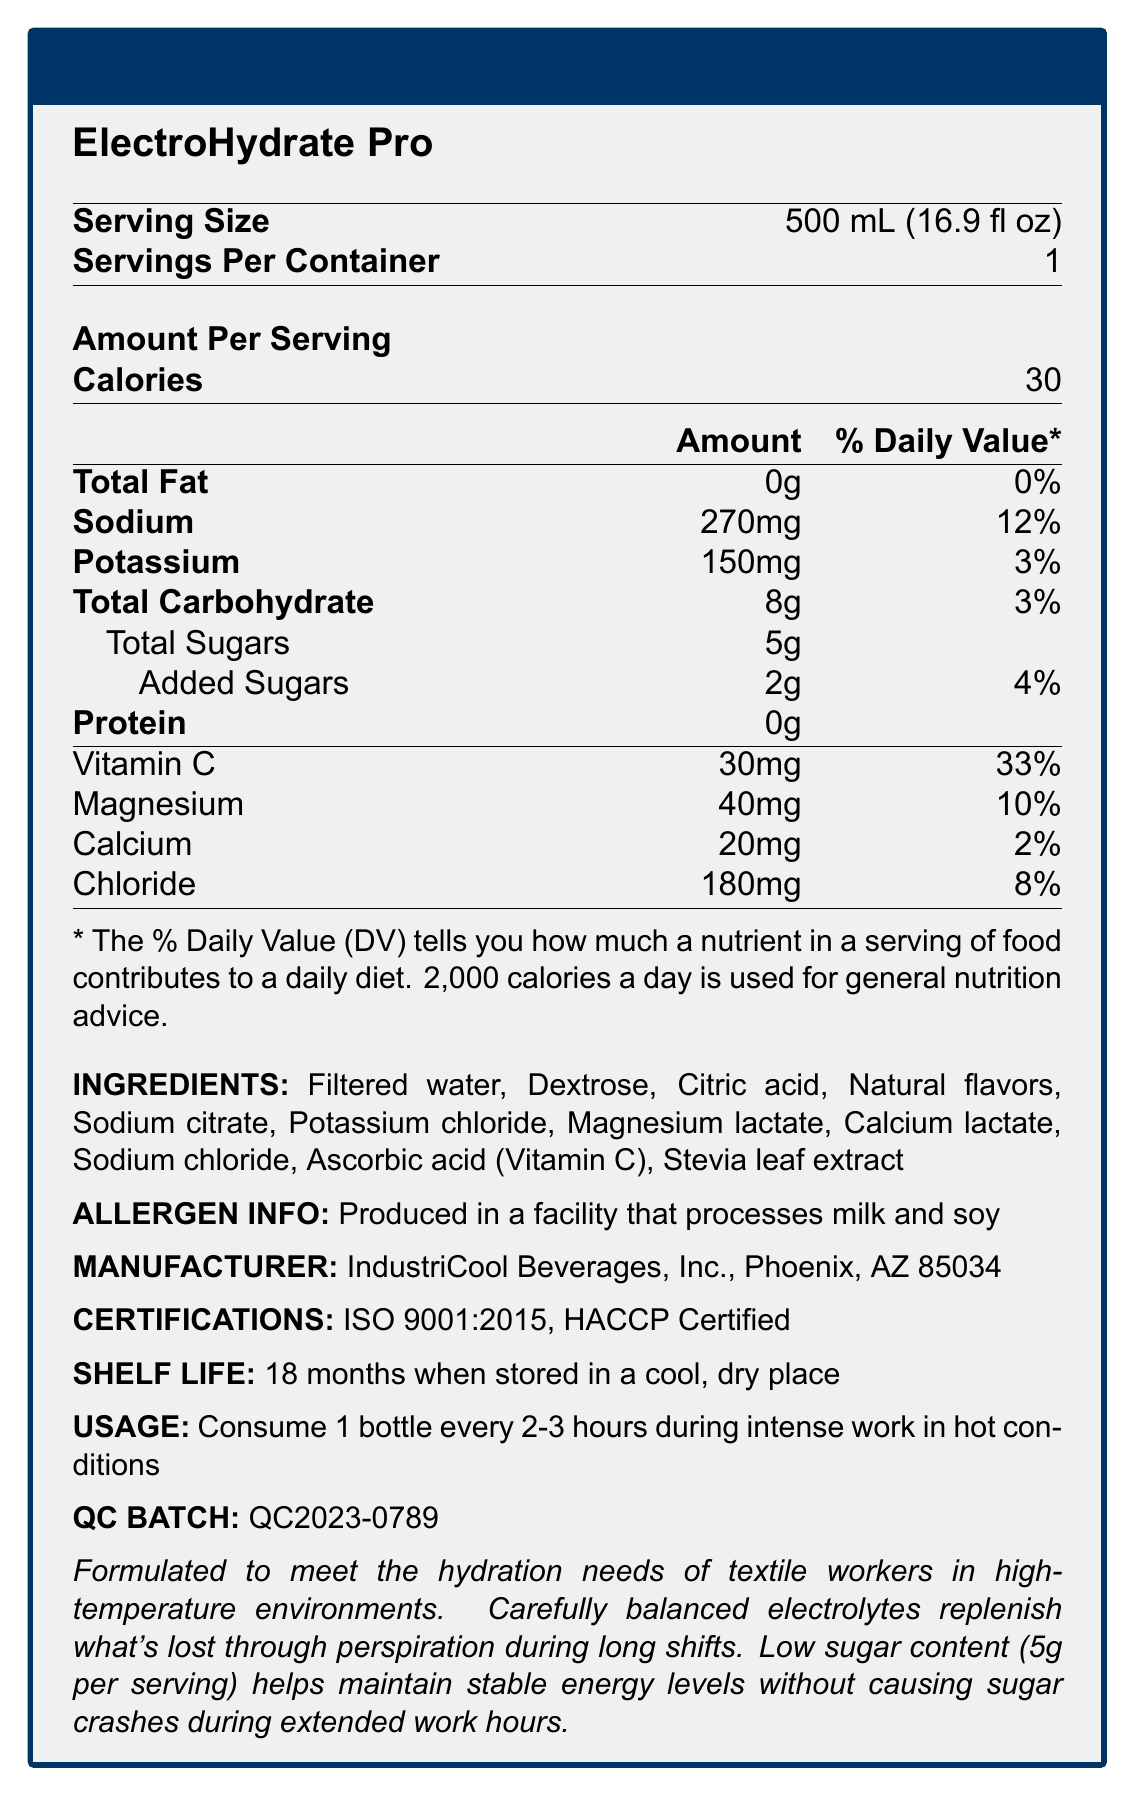what is the serving size of ElectroHydrate Pro? The serving size is listed as "500 mL (16.9 fl oz)" in the Nutrition Facts section of the document.
Answer: 500 mL (16.9 fl oz) How many calories are in one serving of ElectroHydrate Pro? The Nutrition Facts section in the document lists that each serving contains 30 calories.
Answer: 30 calories What is the sodium content per serving and its daily value percentage? The document states that there is 270mg of sodium per serving, which is 12% of the daily value.
Answer: 270mg, 12% Name three electrolytes contained in ElectroHydrate Pro and their amounts per serving. The Nutrition Facts section lists these electrolytes and their amounts per serving.
Answer: Sodium: 270mg, Potassium: 150mg, Magnesium: 40mg What ingredient is used as a sweetener in ElectroHydrate Pro? The Ingredients section lists Stevia leaf extract as one of the ingredients.
Answer: Stevia leaf extract Is ElectroHydrate Pro suitable for people with milk or soy allergies? The Allergen Info section states that the product is produced in a facility that processes milk and soy, which could pose a risk for those with such allergies.
Answer: No What percentage of the daily value of Vitamin C is provided per serving? The Nutrition Facts section states that each serving contains 30mg of Vitamin C, which is 33% of the daily value.
Answer: 33% Where is ElectroHydrate Pro produced? The Manufacturer section specifies that the product is made by IndustriCool Beverages, Inc. in Phoenix, AZ 85034.
Answer: Phoenix, AZ 85034 Under what conditions should ElectroHydrate Pro be stored? The Shelf Life section suggests storing the product in a cool, dry place to ensure it lasts up to 18 months.
Answer: In a cool, dry place For what purpose was ElectroHydrate Pro formulated according to the document? The note at the end of the document mentions that the drink is formulated specifically for textile workers in hot conditions.
Answer: For the hydration needs of textile workers in high-temperature environments How should ElectroHydrate Pro be consumed during intense work in hot conditions? A. 1 bottle every hour B. 1 bottle every 3-4 hours C. 1 bottle every 2-3 hours The Usage section instructs to consume 1 bottle every 2-3 hours during intense work in hot conditions.
Answer: C. 1 bottle every 2-3 hours Which certification does ElectroHydrate Pro NOT have? A. ISO 9001:2015 B. HACCP Certified C. USDA Organic The Certifications section lists ISO 9001:2015 and HACCP Certified, but does not mention USDA Organic.
Answer: C. USDA Organic What is the total amount of sugars per serving, including both natural and added sugars? A. 2g B. 5g C. 7g The document mentions total sugars as 5g, including 2g of added sugars.
Answer: B. 5g Are there any fats in ElectroHydrate Pro? The Nutrition Facts section indicates that there is 0g of total fat per serving.
Answer: No Can you determine if ElectroHydrate Pro contains caffeine? The document does not mention caffeine or lack thereof.
Answer: Cannot be determined What is the quality control batch number for ElectroHydrate Pro? The QC Batch section lists the quality control batch number as QC2023-0789.
Answer: QC2023-0789 Does ElectroHydrate Pro have a low sugar content? The note at the end of the document states that the product has low sugar content (5g per serving), which helps maintain stable energy levels without causing sugar crashes.
Answer: Yes Summarize the main purpose and features of ElectroHydrate Pro. The content and purpose of ElectroHydrate Pro are detailed throughout the document, emphasizing its targeted formulation for high-temperature work environments and balanced nutritional profile.
Answer: ElectroHydrate Pro is a hydration drink specifically formulated for textile workers in high-temperature environments. It has a balanced electrolyte composition to replenish those lost through sweat and contains low sugar to prevent energy crashes. It comes in a 500 mL serving size, offers 30 calories, and includes vitamins and minerals such as Vitamin C, Sodium, Potassium, Magnesium, and Calcium. 